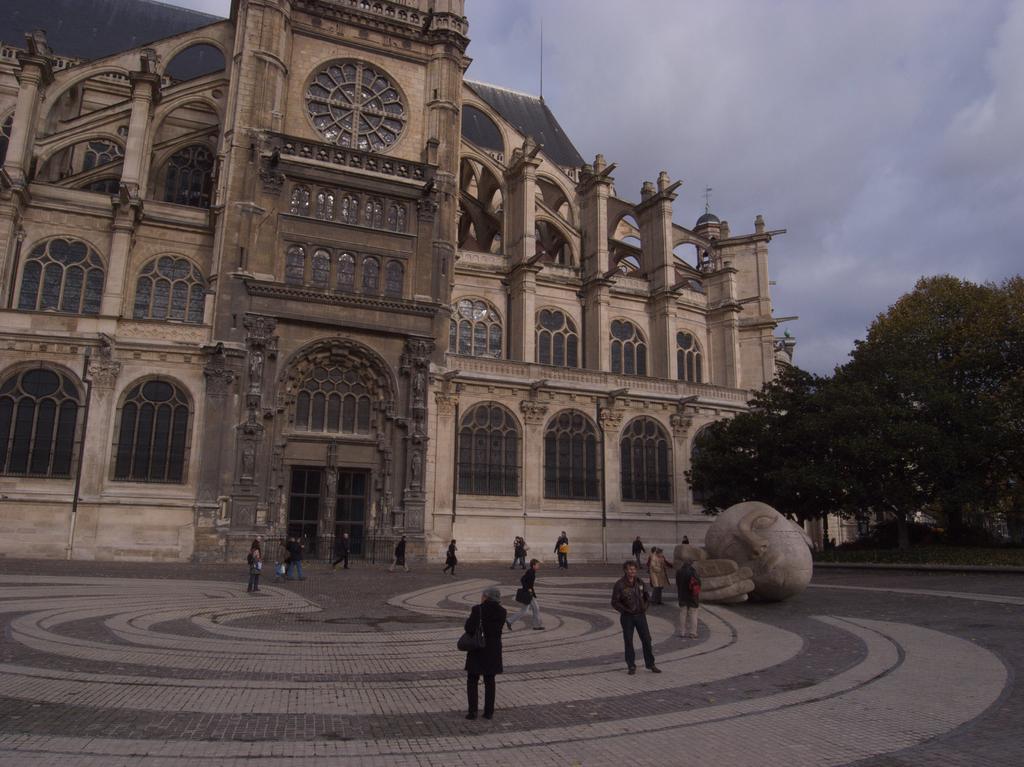How would you summarize this image in a sentence or two? In this picture I can see there is a building and it has windows and there is a statue here. There are few people walking and there are trees onto right side and the sky is clear. 